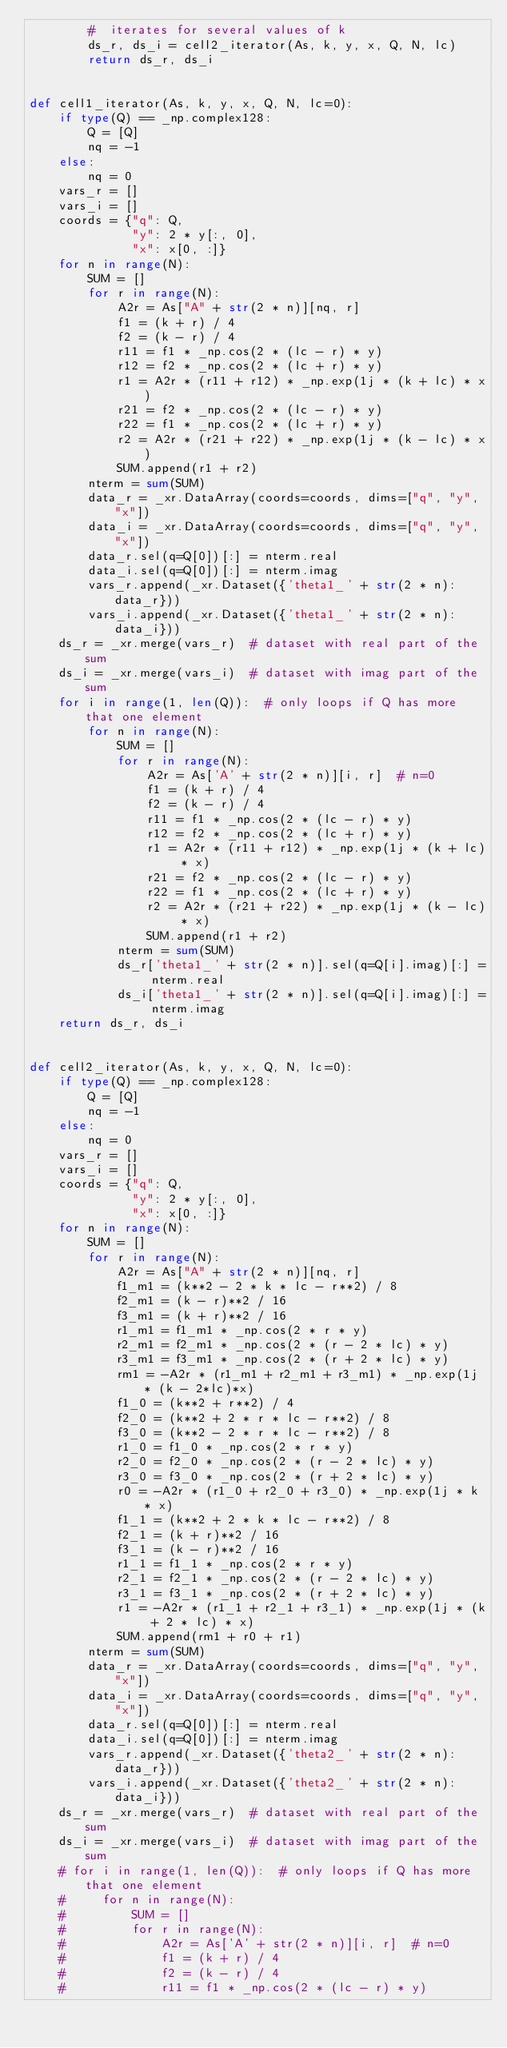Convert code to text. <code><loc_0><loc_0><loc_500><loc_500><_Python_>        #  iterates for several values of k
        ds_r, ds_i = cell2_iterator(As, k, y, x, Q, N, lc)
        return ds_r, ds_i


def cell1_iterator(As, k, y, x, Q, N, lc=0):
    if type(Q) == _np.complex128:
        Q = [Q]
        nq = -1
    else:
        nq = 0
    vars_r = []
    vars_i = []
    coords = {"q": Q,
              "y": 2 * y[:, 0],
              "x": x[0, :]}
    for n in range(N):
        SUM = []
        for r in range(N):
            A2r = As["A" + str(2 * n)][nq, r]
            f1 = (k + r) / 4
            f2 = (k - r) / 4
            r11 = f1 * _np.cos(2 * (lc - r) * y)
            r12 = f2 * _np.cos(2 * (lc + r) * y)
            r1 = A2r * (r11 + r12) * _np.exp(1j * (k + lc) * x)
            r21 = f2 * _np.cos(2 * (lc - r) * y)
            r22 = f1 * _np.cos(2 * (lc + r) * y)
            r2 = A2r * (r21 + r22) * _np.exp(1j * (k - lc) * x)
            SUM.append(r1 + r2)
        nterm = sum(SUM)
        data_r = _xr.DataArray(coords=coords, dims=["q", "y", "x"])
        data_i = _xr.DataArray(coords=coords, dims=["q", "y", "x"])
        data_r.sel(q=Q[0])[:] = nterm.real
        data_i.sel(q=Q[0])[:] = nterm.imag
        vars_r.append(_xr.Dataset({'theta1_' + str(2 * n): data_r}))
        vars_i.append(_xr.Dataset({'theta1_' + str(2 * n): data_i}))
    ds_r = _xr.merge(vars_r)  # dataset with real part of the sum
    ds_i = _xr.merge(vars_i)  # dataset with imag part of the sum
    for i in range(1, len(Q)):  # only loops if Q has more that one element
        for n in range(N):
            SUM = []
            for r in range(N):
                A2r = As['A' + str(2 * n)][i, r]  # n=0
                f1 = (k + r) / 4
                f2 = (k - r) / 4
                r11 = f1 * _np.cos(2 * (lc - r) * y)
                r12 = f2 * _np.cos(2 * (lc + r) * y)
                r1 = A2r * (r11 + r12) * _np.exp(1j * (k + lc) * x)
                r21 = f2 * _np.cos(2 * (lc - r) * y)
                r22 = f1 * _np.cos(2 * (lc + r) * y)
                r2 = A2r * (r21 + r22) * _np.exp(1j * (k - lc) * x)
                SUM.append(r1 + r2)
            nterm = sum(SUM)
            ds_r['theta1_' + str(2 * n)].sel(q=Q[i].imag)[:] = nterm.real
            ds_i['theta1_' + str(2 * n)].sel(q=Q[i].imag)[:] = nterm.imag
    return ds_r, ds_i


def cell2_iterator(As, k, y, x, Q, N, lc=0):
    if type(Q) == _np.complex128:
        Q = [Q]
        nq = -1
    else:
        nq = 0
    vars_r = []
    vars_i = []
    coords = {"q": Q,
              "y": 2 * y[:, 0],
              "x": x[0, :]}
    for n in range(N):
        SUM = []
        for r in range(N):
            A2r = As["A" + str(2 * n)][nq, r]
            f1_m1 = (k**2 - 2 * k * lc - r**2) / 8
            f2_m1 = (k - r)**2 / 16
            f3_m1 = (k + r)**2 / 16
            r1_m1 = f1_m1 * _np.cos(2 * r * y)
            r2_m1 = f2_m1 * _np.cos(2 * (r - 2 * lc) * y)
            r3_m1 = f3_m1 * _np.cos(2 * (r + 2 * lc) * y)
            rm1 = -A2r * (r1_m1 + r2_m1 + r3_m1) * _np.exp(1j * (k - 2*lc)*x)
            f1_0 = (k**2 + r**2) / 4
            f2_0 = (k**2 + 2 * r * lc - r**2) / 8
            f3_0 = (k**2 - 2 * r * lc - r**2) / 8
            r1_0 = f1_0 * _np.cos(2 * r * y)
            r2_0 = f2_0 * _np.cos(2 * (r - 2 * lc) * y)
            r3_0 = f3_0 * _np.cos(2 * (r + 2 * lc) * y)
            r0 = -A2r * (r1_0 + r2_0 + r3_0) * _np.exp(1j * k * x)
            f1_1 = (k**2 + 2 * k * lc - r**2) / 8
            f2_1 = (k + r)**2 / 16
            f3_1 = (k - r)**2 / 16
            r1_1 = f1_1 * _np.cos(2 * r * y)
            r2_1 = f2_1 * _np.cos(2 * (r - 2 * lc) * y)
            r3_1 = f3_1 * _np.cos(2 * (r + 2 * lc) * y)
            r1 = -A2r * (r1_1 + r2_1 + r3_1) * _np.exp(1j * (k + 2 * lc) * x)
            SUM.append(rm1 + r0 + r1)
        nterm = sum(SUM)
        data_r = _xr.DataArray(coords=coords, dims=["q", "y", "x"])
        data_i = _xr.DataArray(coords=coords, dims=["q", "y", "x"])
        data_r.sel(q=Q[0])[:] = nterm.real
        data_i.sel(q=Q[0])[:] = nterm.imag
        vars_r.append(_xr.Dataset({'theta2_' + str(2 * n): data_r}))
        vars_i.append(_xr.Dataset({'theta2_' + str(2 * n): data_i}))
    ds_r = _xr.merge(vars_r)  # dataset with real part of the sum
    ds_i = _xr.merge(vars_i)  # dataset with imag part of the sum
    # for i in range(1, len(Q)):  # only loops if Q has more that one element
    #     for n in range(N):
    #         SUM = []
    #         for r in range(N):
    #             A2r = As['A' + str(2 * n)][i, r]  # n=0
    #             f1 = (k + r) / 4
    #             f2 = (k - r) / 4
    #             r11 = f1 * _np.cos(2 * (lc - r) * y)</code> 